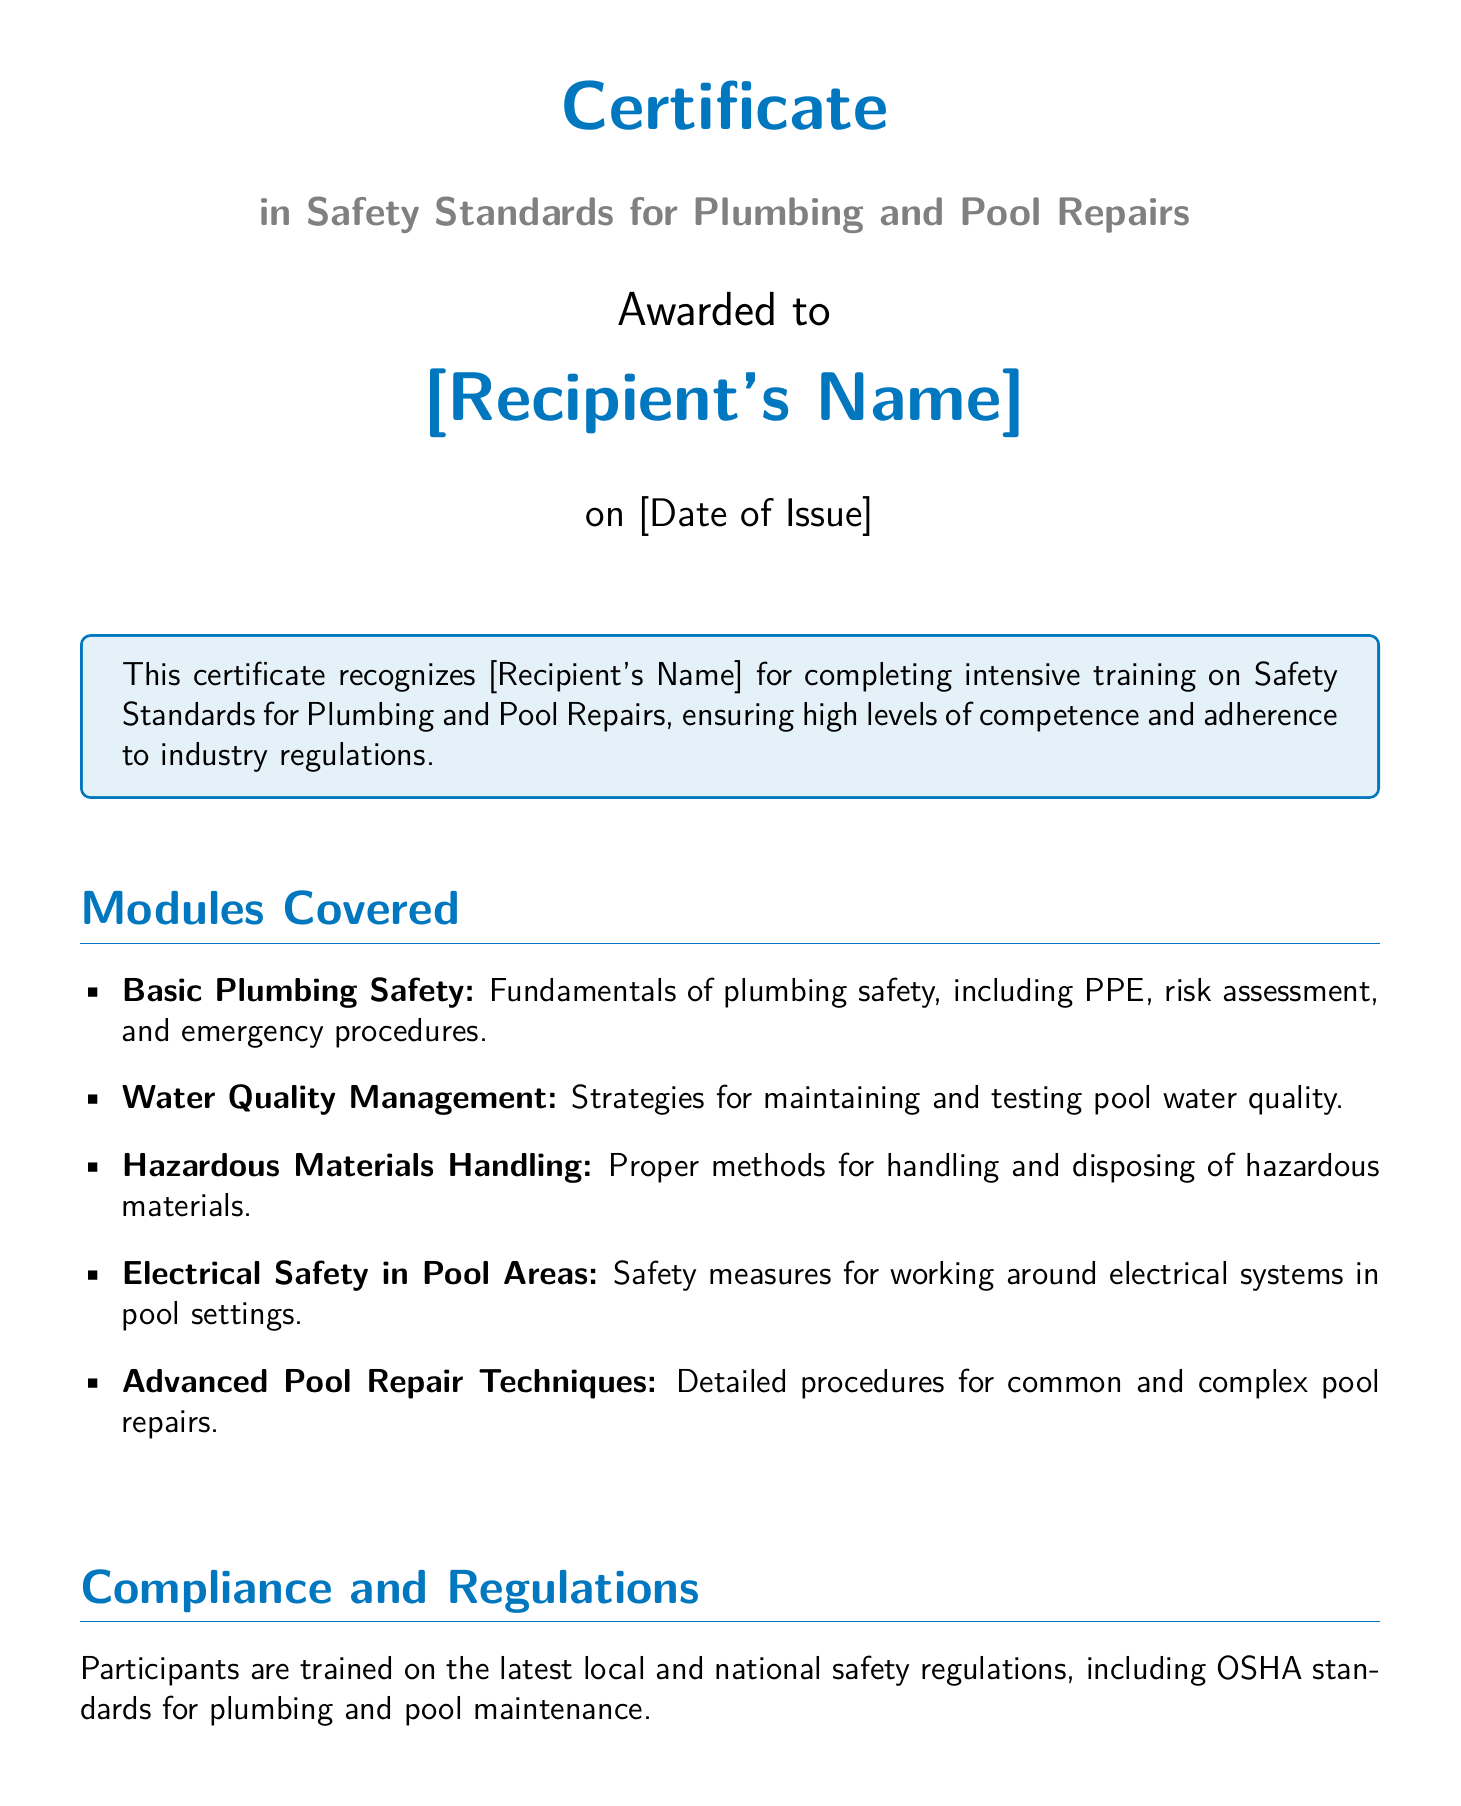What is the title of the certificate? The title is the main heading presented prominently in the document, which describes the purpose of the certificate.
Answer: Certificate in Safety Standards for Plumbing and Pool Repairs Who is the certificate awarded to? The document contains a placeholder for the recipient's name, which is indicated after "Awarded to."
Answer: [Recipient's Name] When was the certificate issued? The date of issue is specified in the document and is presented after the recipient's name.
Answer: [Date of Issue] What organization issued the certificate? At the bottom of the document, the issuing organization is clearly stated.
Answer: National Institute of Plumbing and Pool Services Name one module covered in the training. The document lists several modules, and the answer is any one of them has been discussed.
Answer: Basic Plumbing Safety What is included in the certification process? The certification process is described in terms of evaluations performed to assess competence.
Answer: Theoretical exams and practical evaluations What type of safety regulations are participants trained on? The document specifies the kind of regulations participants learn about, which is related to safety standards.
Answer: OSHA standards Who is the Chairman mentioned in the document? The document includes a name as the signatory in the lower section, identifying the Chairman.
Answer: John M. Smith What color is used for the section titles? The document specifies the color used for section titles, making it visually identifiable.
Answer: poolblue 